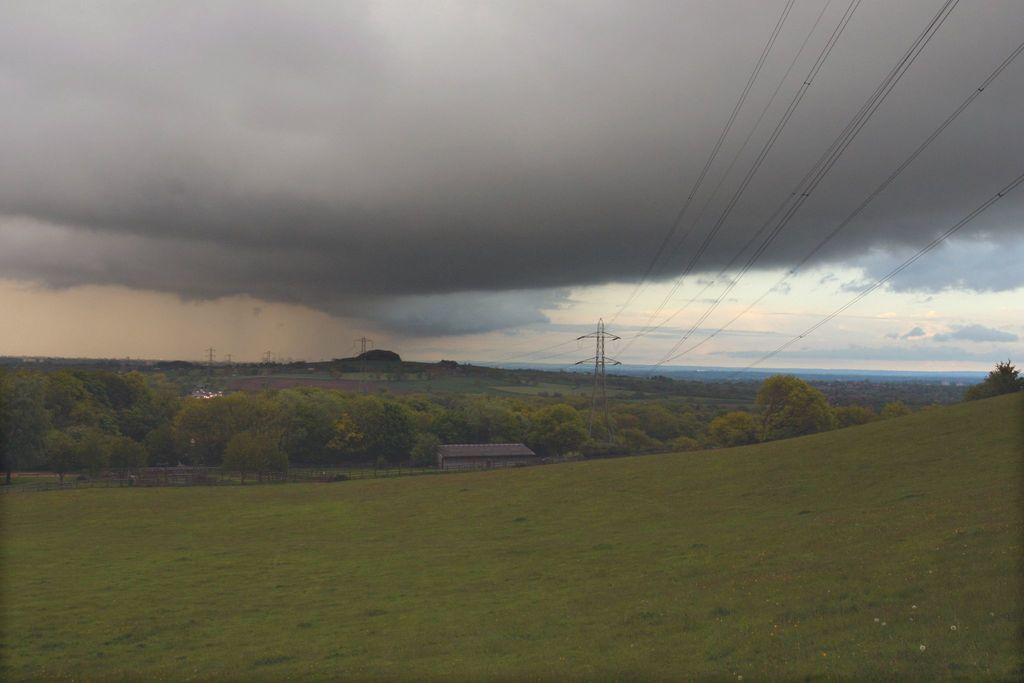What type of vegetation can be seen in the image? There are trees in the image. What structures are present in the image? There are sheds in the image. What else can be seen in the image besides trees and sheds? There are poles with wires in the image. What is visible at the bottom of the image? The ground is visible at the bottom of the image. What is visible at the top of the image? The sky is visible at the top of the image. What type of plane can be seen in the image? There is no plane present in the image. What is the mind's role in the image? The image does not depict a mind or any mental processes; it is a visual representation of physical objects. 